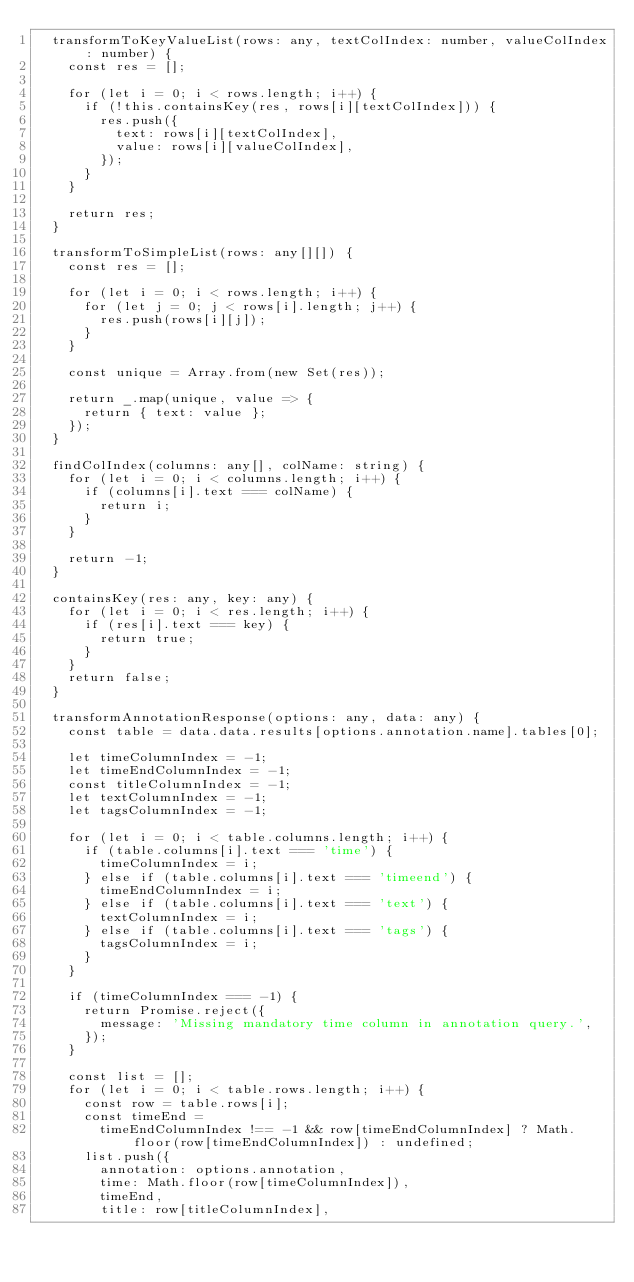<code> <loc_0><loc_0><loc_500><loc_500><_TypeScript_>  transformToKeyValueList(rows: any, textColIndex: number, valueColIndex: number) {
    const res = [];

    for (let i = 0; i < rows.length; i++) {
      if (!this.containsKey(res, rows[i][textColIndex])) {
        res.push({
          text: rows[i][textColIndex],
          value: rows[i][valueColIndex],
        });
      }
    }

    return res;
  }

  transformToSimpleList(rows: any[][]) {
    const res = [];

    for (let i = 0; i < rows.length; i++) {
      for (let j = 0; j < rows[i].length; j++) {
        res.push(rows[i][j]);
      }
    }

    const unique = Array.from(new Set(res));

    return _.map(unique, value => {
      return { text: value };
    });
  }

  findColIndex(columns: any[], colName: string) {
    for (let i = 0; i < columns.length; i++) {
      if (columns[i].text === colName) {
        return i;
      }
    }

    return -1;
  }

  containsKey(res: any, key: any) {
    for (let i = 0; i < res.length; i++) {
      if (res[i].text === key) {
        return true;
      }
    }
    return false;
  }

  transformAnnotationResponse(options: any, data: any) {
    const table = data.data.results[options.annotation.name].tables[0];

    let timeColumnIndex = -1;
    let timeEndColumnIndex = -1;
    const titleColumnIndex = -1;
    let textColumnIndex = -1;
    let tagsColumnIndex = -1;

    for (let i = 0; i < table.columns.length; i++) {
      if (table.columns[i].text === 'time') {
        timeColumnIndex = i;
      } else if (table.columns[i].text === 'timeend') {
        timeEndColumnIndex = i;
      } else if (table.columns[i].text === 'text') {
        textColumnIndex = i;
      } else if (table.columns[i].text === 'tags') {
        tagsColumnIndex = i;
      }
    }

    if (timeColumnIndex === -1) {
      return Promise.reject({
        message: 'Missing mandatory time column in annotation query.',
      });
    }

    const list = [];
    for (let i = 0; i < table.rows.length; i++) {
      const row = table.rows[i];
      const timeEnd =
        timeEndColumnIndex !== -1 && row[timeEndColumnIndex] ? Math.floor(row[timeEndColumnIndex]) : undefined;
      list.push({
        annotation: options.annotation,
        time: Math.floor(row[timeColumnIndex]),
        timeEnd,
        title: row[titleColumnIndex],</code> 